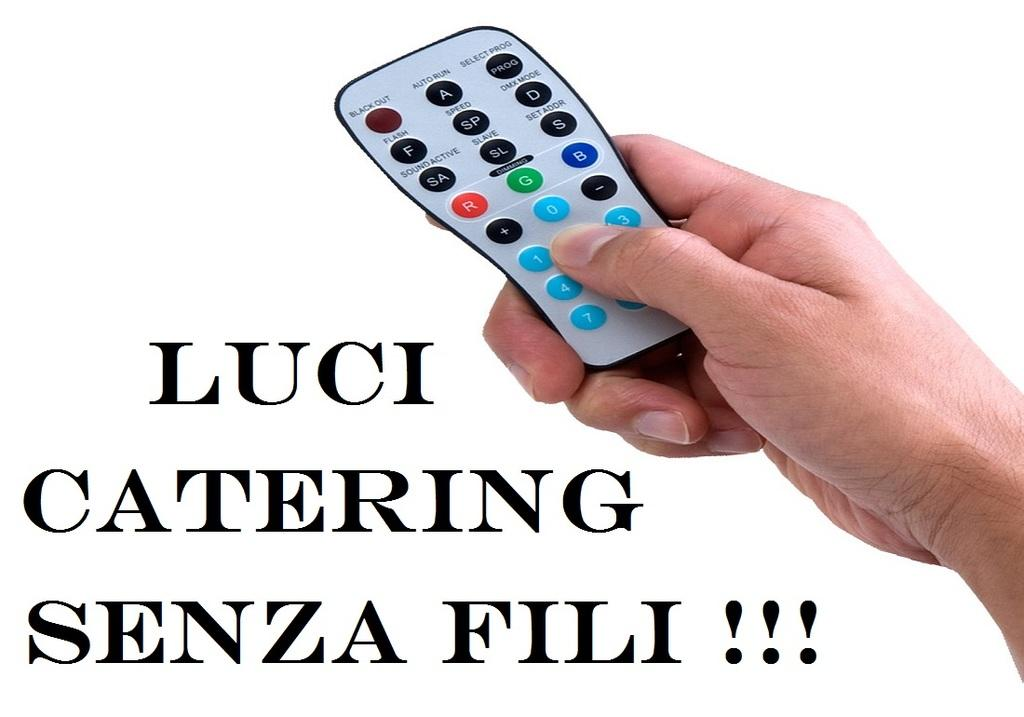Provide a one-sentence caption for the provided image. a photo of a remote with the quote "Luci Catering Senza Fili!!!". 